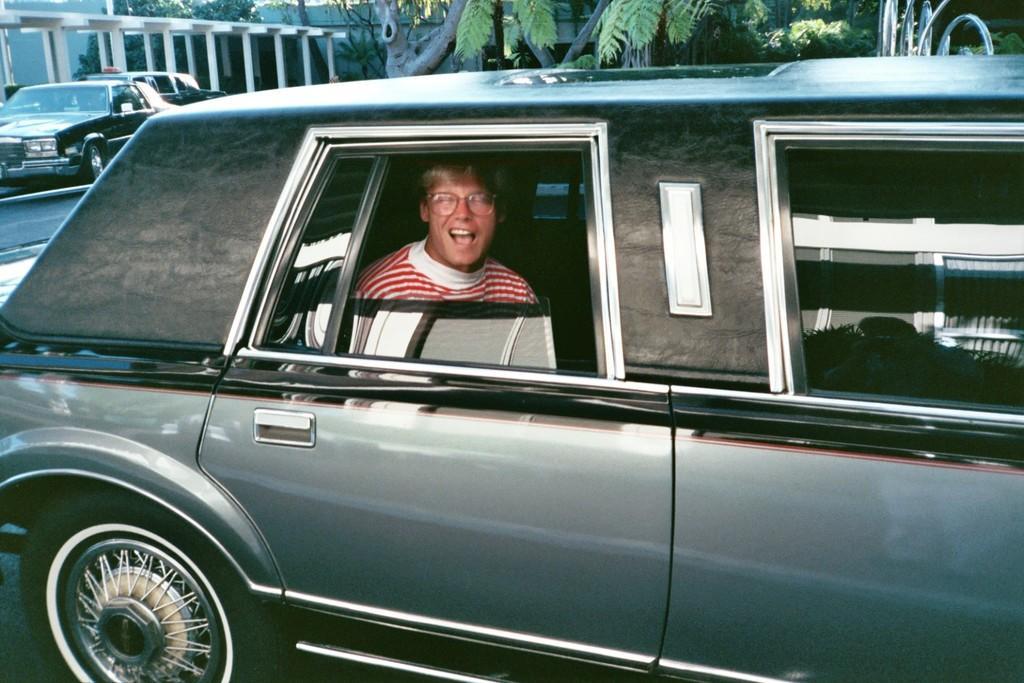In one or two sentences, can you explain what this image depicts? In this image, in the middle, we can see a car. In the car, we can see a man sitting. On the left side, we can see few cars, pillars, trees. In the background, we can see trees and a metal rod. At the bottom, we can see a road. 